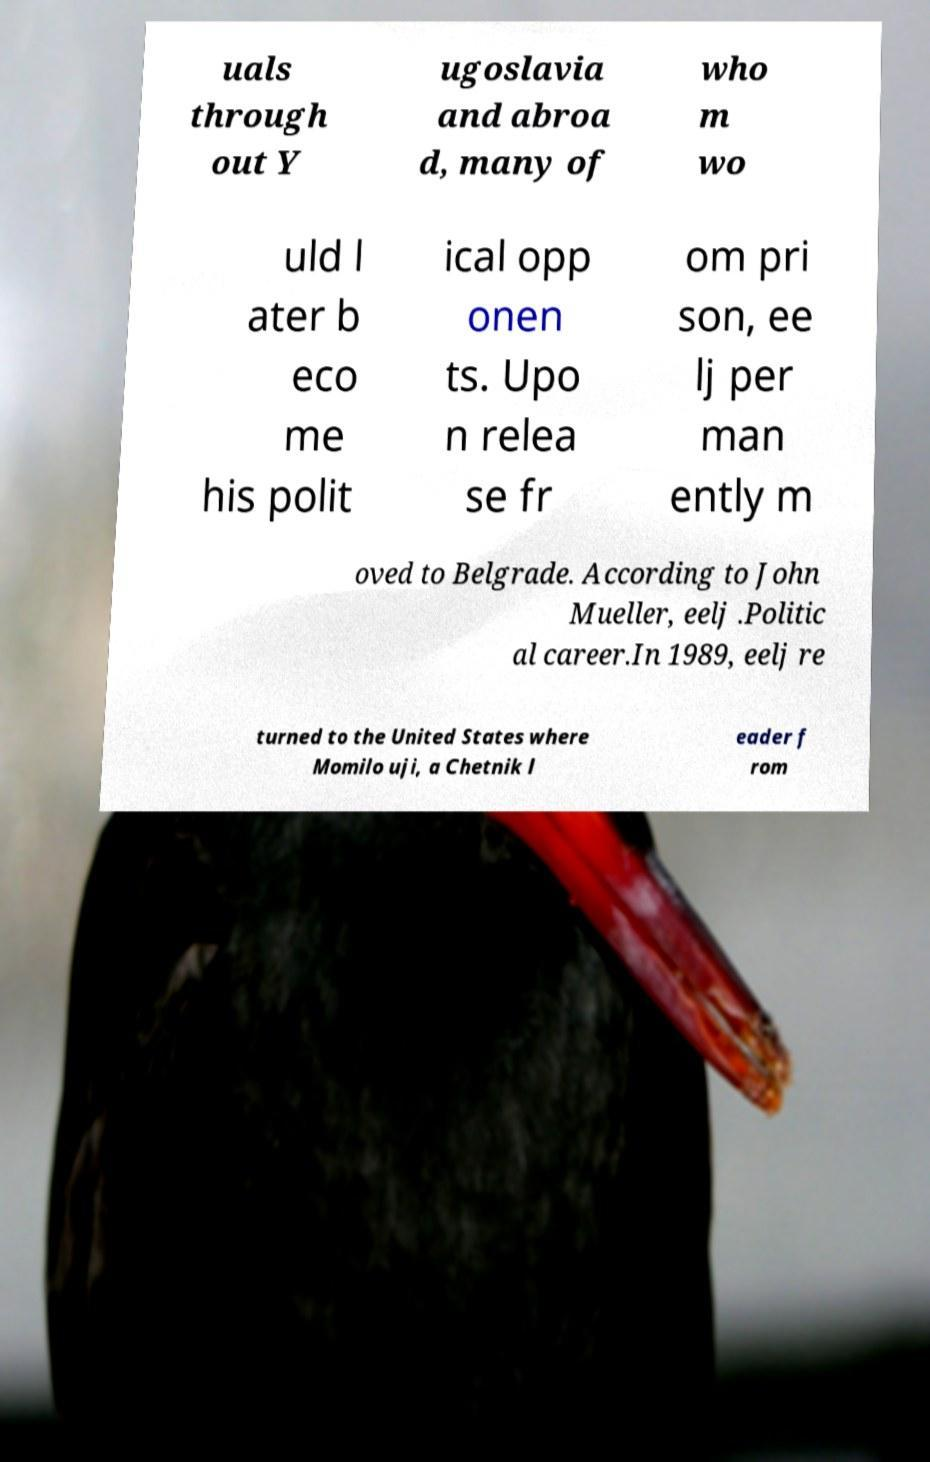Can you accurately transcribe the text from the provided image for me? uals through out Y ugoslavia and abroa d, many of who m wo uld l ater b eco me his polit ical opp onen ts. Upo n relea se fr om pri son, ee lj per man ently m oved to Belgrade. According to John Mueller, eelj .Politic al career.In 1989, eelj re turned to the United States where Momilo uji, a Chetnik l eader f rom 